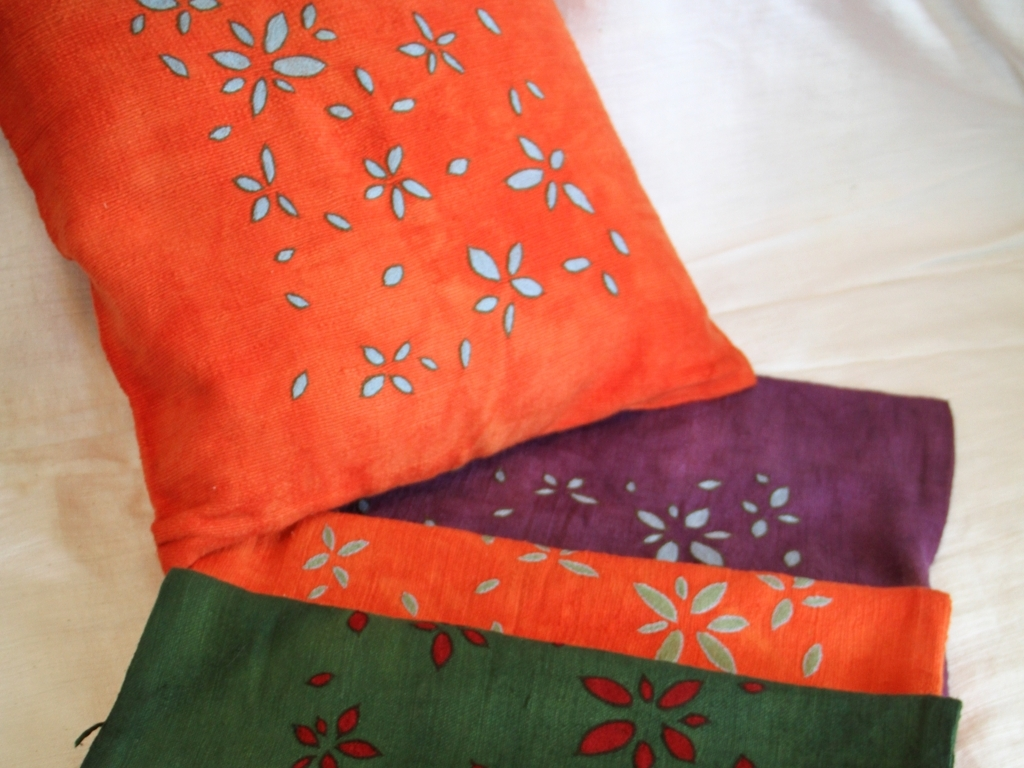What might be the use for these fabrics? These fabrics likely have versatile uses, ranging from being sewn into garments such as dresses or shirts to home decorations like curtains, tablecloths, or even festive banners. Their vivid colors and patterns suggest they could be used in settings that celebrate color and traditional design. 